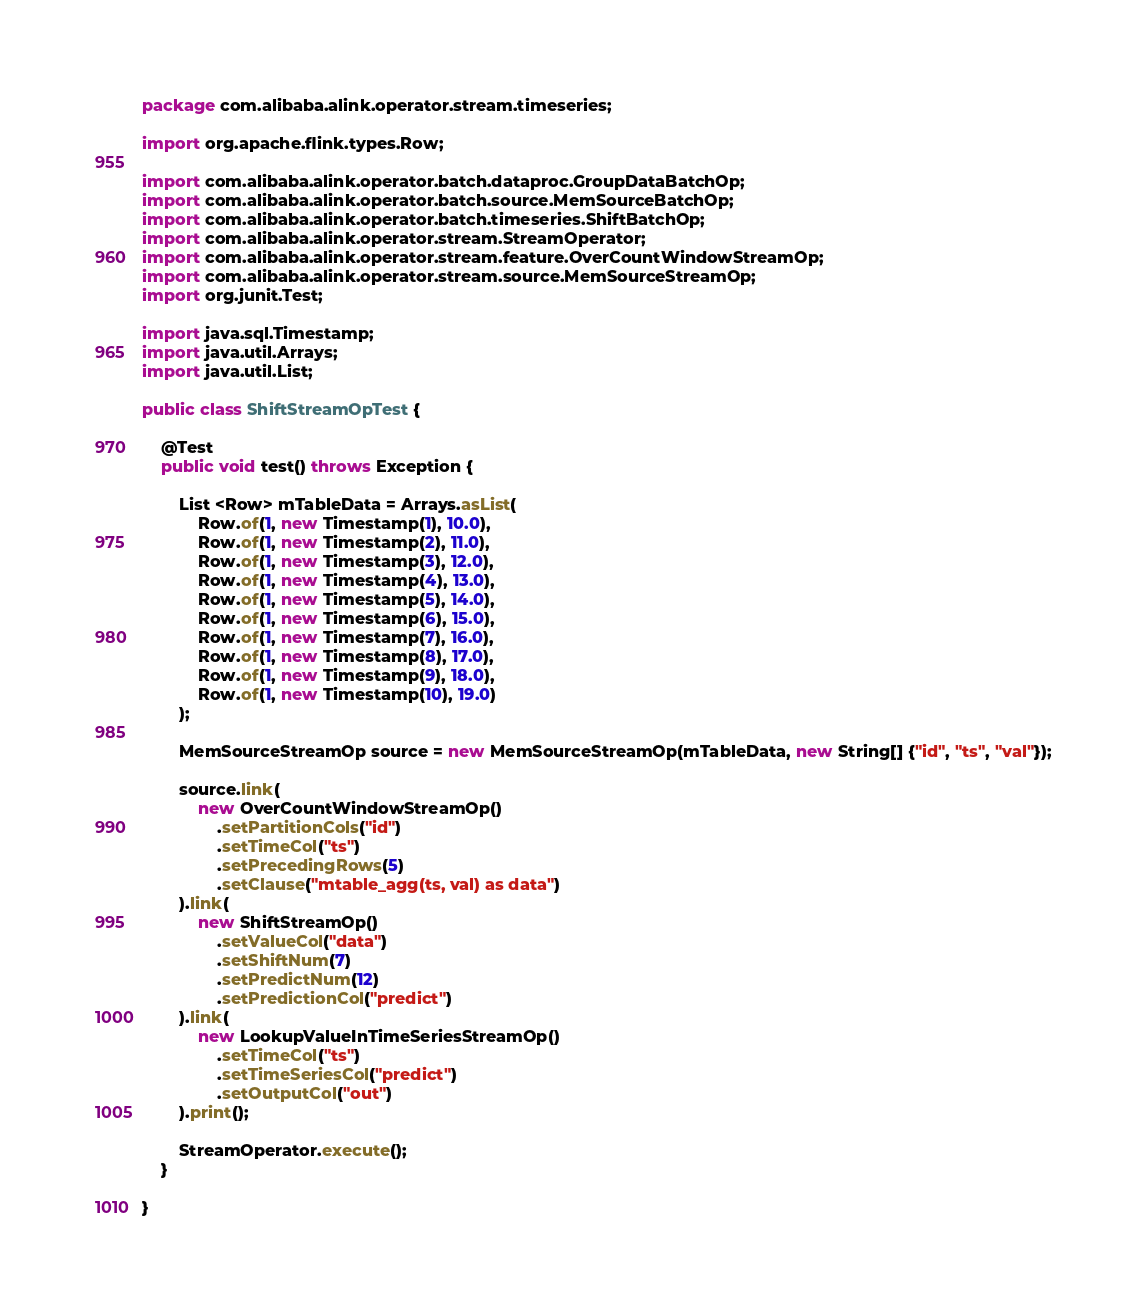<code> <loc_0><loc_0><loc_500><loc_500><_Java_>package com.alibaba.alink.operator.stream.timeseries;

import org.apache.flink.types.Row;

import com.alibaba.alink.operator.batch.dataproc.GroupDataBatchOp;
import com.alibaba.alink.operator.batch.source.MemSourceBatchOp;
import com.alibaba.alink.operator.batch.timeseries.ShiftBatchOp;
import com.alibaba.alink.operator.stream.StreamOperator;
import com.alibaba.alink.operator.stream.feature.OverCountWindowStreamOp;
import com.alibaba.alink.operator.stream.source.MemSourceStreamOp;
import org.junit.Test;

import java.sql.Timestamp;
import java.util.Arrays;
import java.util.List;

public class ShiftStreamOpTest {

	@Test
	public void test() throws Exception {

		List <Row> mTableData = Arrays.asList(
			Row.of(1, new Timestamp(1), 10.0),
			Row.of(1, new Timestamp(2), 11.0),
			Row.of(1, new Timestamp(3), 12.0),
			Row.of(1, new Timestamp(4), 13.0),
			Row.of(1, new Timestamp(5), 14.0),
			Row.of(1, new Timestamp(6), 15.0),
			Row.of(1, new Timestamp(7), 16.0),
			Row.of(1, new Timestamp(8), 17.0),
			Row.of(1, new Timestamp(9), 18.0),
			Row.of(1, new Timestamp(10), 19.0)
		);

		MemSourceStreamOp source = new MemSourceStreamOp(mTableData, new String[] {"id", "ts", "val"});

		source.link(
			new OverCountWindowStreamOp()
				.setPartitionCols("id")
				.setTimeCol("ts")
				.setPrecedingRows(5)
				.setClause("mtable_agg(ts, val) as data")
		).link(
			new ShiftStreamOp()
				.setValueCol("data")
				.setShiftNum(7)
				.setPredictNum(12)
				.setPredictionCol("predict")
		).link(
			new LookupValueInTimeSeriesStreamOp()
				.setTimeCol("ts")
				.setTimeSeriesCol("predict")
				.setOutputCol("out")
		).print();

		StreamOperator.execute();
	}

}</code> 